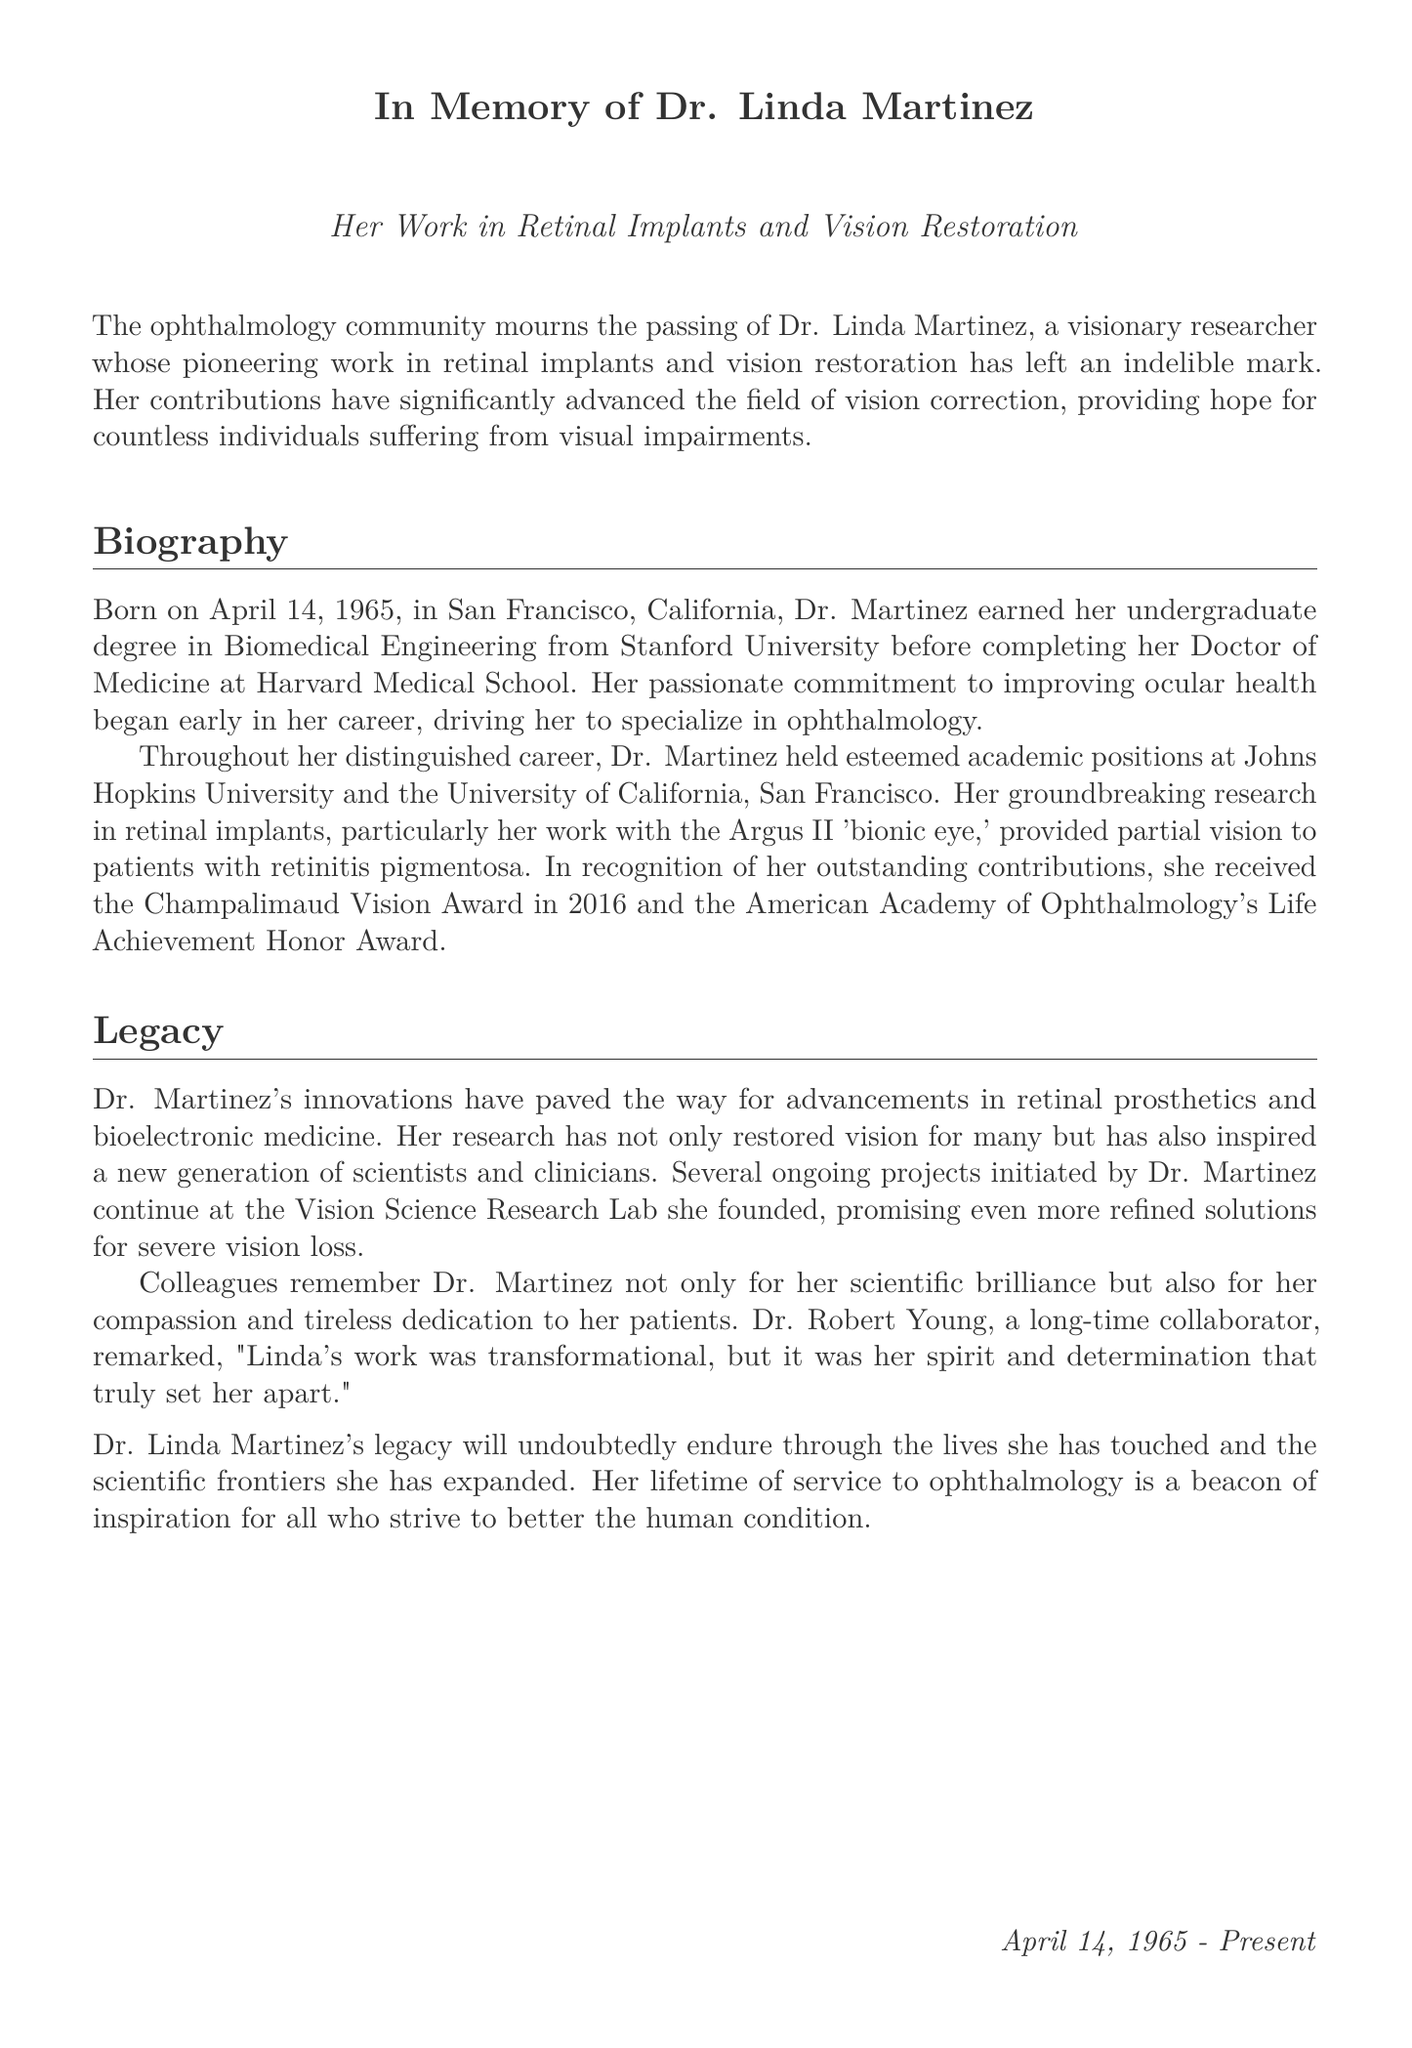What is Dr. Linda Martinez known for? Dr. Linda Martinez is known for her pioneering work in retinal implants and vision restoration.
Answer: retinal implants and vision restoration When was Dr. Linda Martinez born? The document states that Dr. Linda Martinez was born on April 14, 1965.
Answer: April 14, 1965 What university did Dr. Martinez attend for her undergraduate degree? The biography mentions that Dr. Martinez earned her undergraduate degree in Biomedical Engineering from Stanford University.
Answer: Stanford University What significant award did Dr. Martinez receive in 2016? The document states that she received the Champalimaud Vision Award in 2016.
Answer: Champalimaud Vision Award What condition was the Argus II 'bionic eye' associated with? The document specifies that the Argus II 'bionic eye' provided partial vision to patients with retinitis pigmentosa.
Answer: retinitis pigmentosa How did colleagues describe Dr. Martinez's contributions? Colleagues remembered her for her scientific brilliance and compassion in patient care.
Answer: scientific brilliance and compassion What ongoing initiative did Dr. Martinez initiate? Dr. Martinez founded the Vision Science Research Lab, where ongoing projects continue.
Answer: Vision Science Research Lab What role did Dr. Martinez have at Johns Hopkins University? The document indicates that she held an esteemed academic position at Johns Hopkins University.
Answer: esteemed academic position What qualities made Dr. Martinez stand out according to Dr. Robert Young? Dr. Robert Young noted that her spirit and determination set her apart.
Answer: spirit and determination 